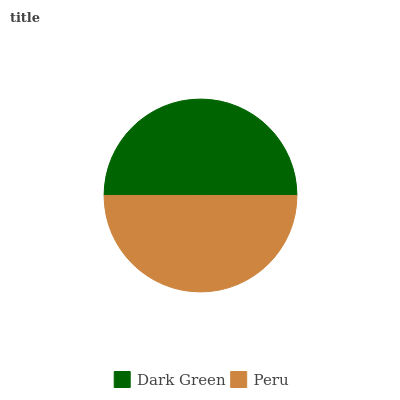Is Peru the minimum?
Answer yes or no. Yes. Is Dark Green the maximum?
Answer yes or no. Yes. Is Peru the maximum?
Answer yes or no. No. Is Dark Green greater than Peru?
Answer yes or no. Yes. Is Peru less than Dark Green?
Answer yes or no. Yes. Is Peru greater than Dark Green?
Answer yes or no. No. Is Dark Green less than Peru?
Answer yes or no. No. Is Dark Green the high median?
Answer yes or no. Yes. Is Peru the low median?
Answer yes or no. Yes. Is Peru the high median?
Answer yes or no. No. Is Dark Green the low median?
Answer yes or no. No. 